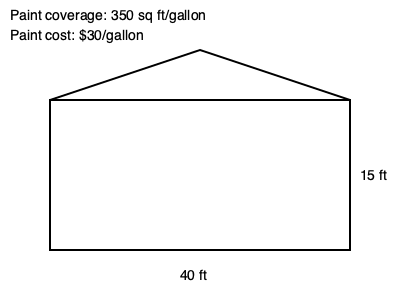As an estate agent assisting the church, you need to estimate the cost of repainting the exterior of the church building shown in the elevation drawing. Given that the paint coverage is 350 sq ft/gallon and the paint costs $30/gallon, what is the estimated cost of paint needed for this project? To estimate the cost of paint, we need to follow these steps:

1. Calculate the total surface area to be painted:
   a. Rectangle area: $40 \text{ ft} \times 15 \text{ ft} = 600 \text{ sq ft}$
   b. Triangle area: $\frac{1}{2} \times 40 \text{ ft} \times 15 \text{ ft} = 300 \text{ sq ft}$
   c. Total area: $600 \text{ sq ft} + 300 \text{ sq ft} = 900 \text{ sq ft}$

2. Calculate the number of gallons needed:
   $\text{Gallons} = \frac{\text{Total area}}{\text{Coverage per gallon}} = \frac{900 \text{ sq ft}}{350 \text{ sq ft/gallon}} \approx 2.57 \text{ gallons}$

3. Round up to the nearest whole gallon: 3 gallons

4. Calculate the total cost:
   $\text{Cost} = 3 \text{ gallons} \times \$30/\text{gallon} = \$90$

Therefore, the estimated cost of paint needed for this project is $90.
Answer: $90 